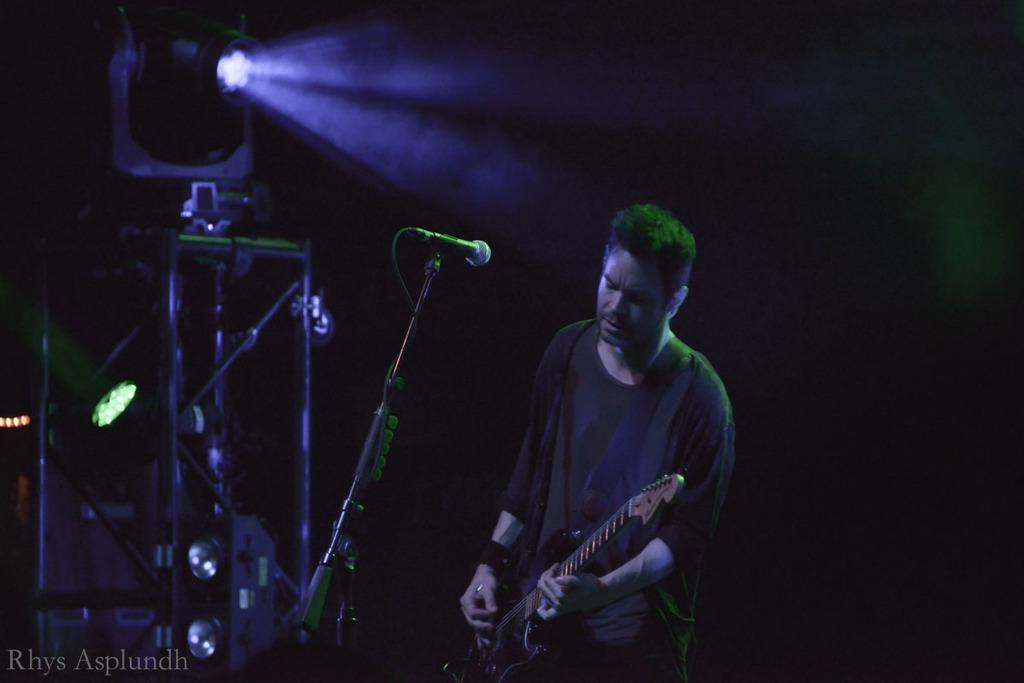Please provide a concise description of this image. In the image we can see there is a person who is standing and holding guitar in his hand. 